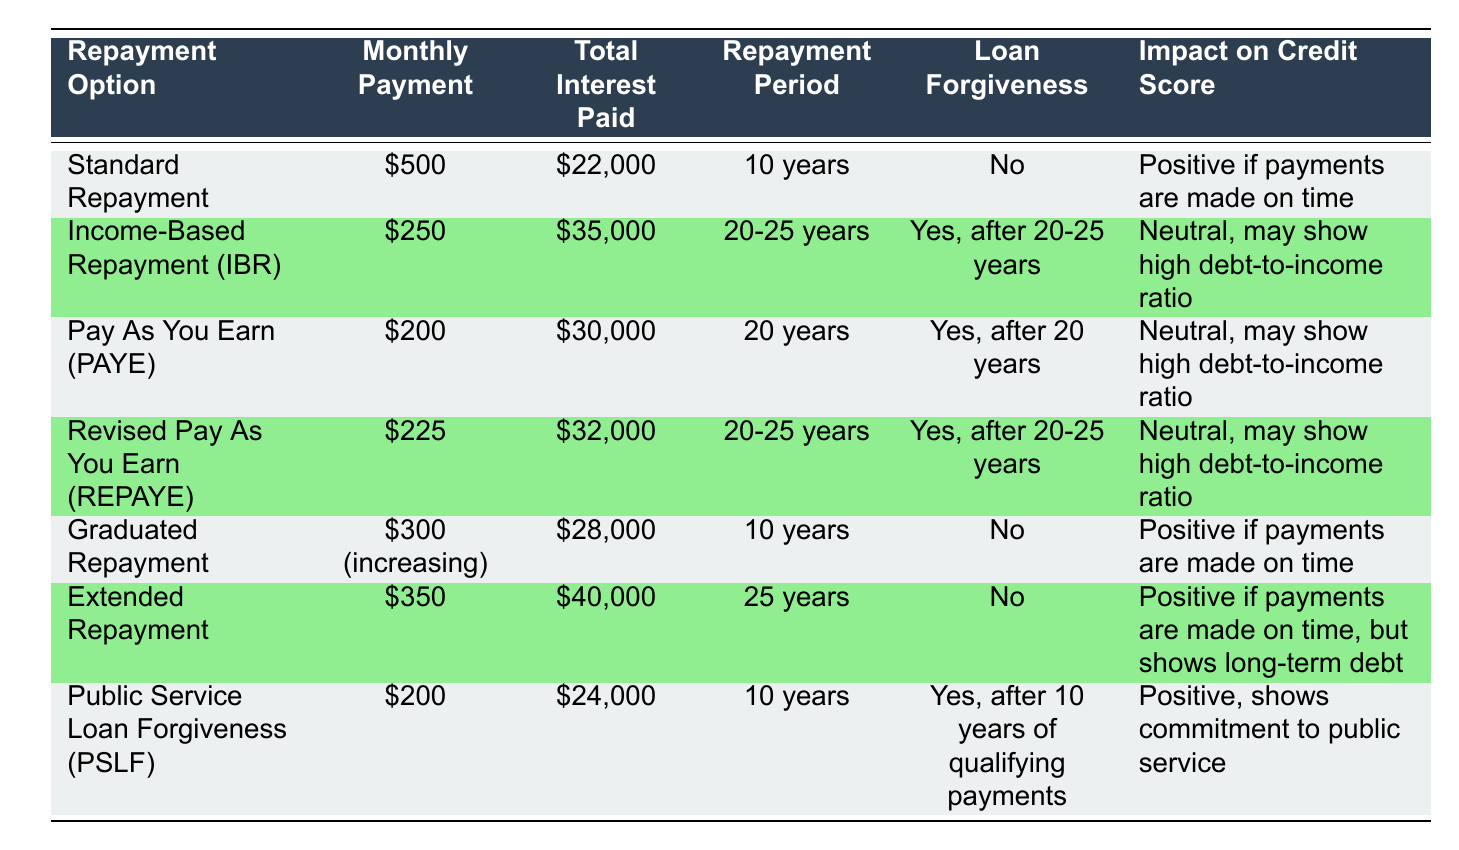What is the monthly payment for the Standard Repayment option? The table lists the monthly payment for Standard Repayment as $500, which is directly indicated in the "Monthly Payment" column corresponding to this option.
Answer: $500 How much total interest will be paid under the Income-Based Repayment option? The total interest paid under the Income-Based Repayment option is $35,000, which is found in the "Total Interest Paid" column for this row in the table.
Answer: $35,000 Which repayment options offer loan forgiveness? The options that offer loan forgiveness are highlighted as "Yes" in the "Loan Forgiveness" column. This includes Income-Based Repayment (IBR), Pay As You Earn (PAYE), Revised Pay As You Earn (REPAYE), and Public Service Loan Forgiveness (PSLF).
Answer: IBR, PAYE, REPAYE, PSLF What is the difference in total interest paid between Standard Repayment and Graduated Repayment? The total interest paid for Standard Repayment is $22,000 and for Graduated Repayment it is $28,000. The difference is calculated by subtracting $22,000 from $28,000: $28,000 - $22,000 = $6,000.
Answer: $6,000 Is the impact on credit score for Pay As You Earn (PAYE) positive? The impact on credit score for PAYE is listed as "Neutral, may show high debt-to-income ratio," which indicates that it is not positive. Thus, the answer is no.
Answer: No How does the repayment period compare for the longest and shortest repayment options? The longest repayment period in the table is 25 years for Extended Repayment, while the shortest repayment period is 10 years for Standard Repayment and Public Service Loan Forgiveness (PSLF). The difference in years is 25 - 10 = 15 years, showing a significant difference.
Answer: 15 years For which repayment option is the monthly payment the lowest, and what is that amount? Income-Based Repayment (IBR) has the lowest monthly payment of $250, as indicated in the "Monthly Payment" column.
Answer: $250 Which repayment option has both a positive impact on the credit score and no loan forgiveness? The repayment options with a positive impact on credit score that do not offer loan forgiveness are Standard Repayment and Graduated Repayment.
Answer: Standard Repayment, Graduated Repayment 